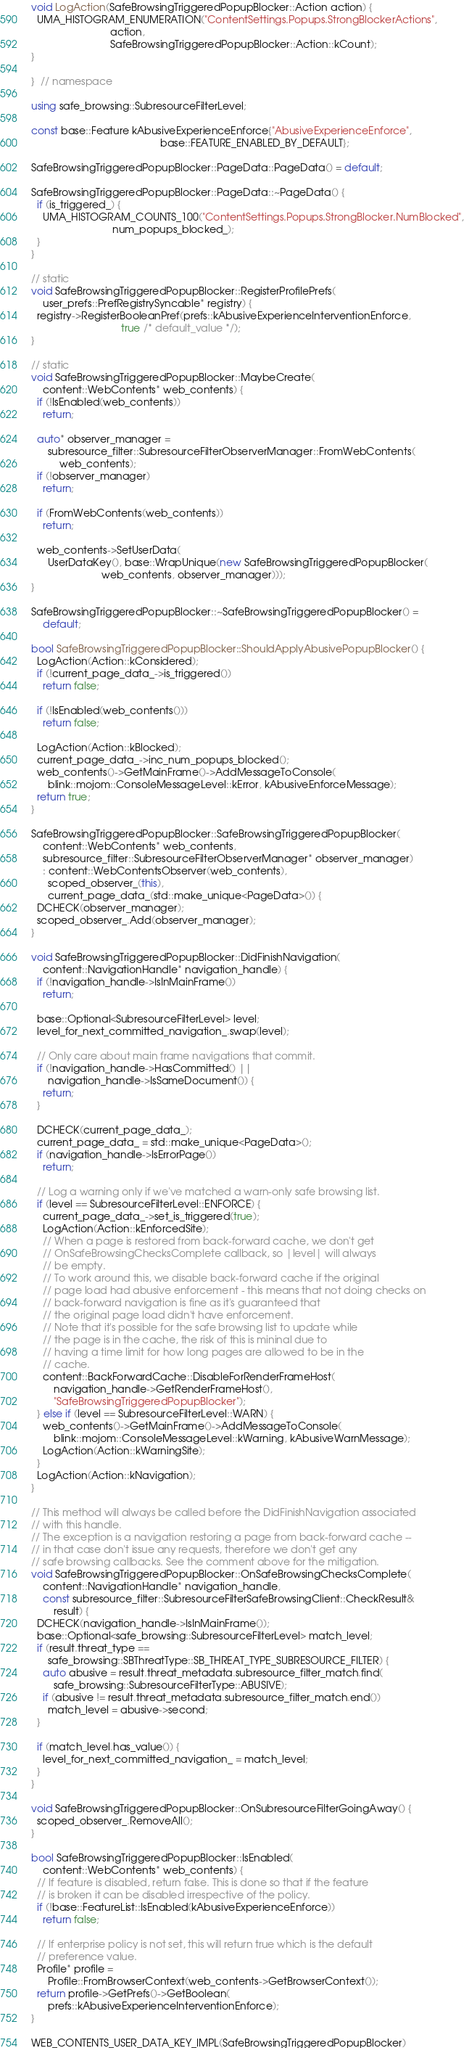Convert code to text. <code><loc_0><loc_0><loc_500><loc_500><_C++_>
void LogAction(SafeBrowsingTriggeredPopupBlocker::Action action) {
  UMA_HISTOGRAM_ENUMERATION("ContentSettings.Popups.StrongBlockerActions",
                            action,
                            SafeBrowsingTriggeredPopupBlocker::Action::kCount);
}

}  // namespace

using safe_browsing::SubresourceFilterLevel;

const base::Feature kAbusiveExperienceEnforce{"AbusiveExperienceEnforce",
                                              base::FEATURE_ENABLED_BY_DEFAULT};

SafeBrowsingTriggeredPopupBlocker::PageData::PageData() = default;

SafeBrowsingTriggeredPopupBlocker::PageData::~PageData() {
  if (is_triggered_) {
    UMA_HISTOGRAM_COUNTS_100("ContentSettings.Popups.StrongBlocker.NumBlocked",
                             num_popups_blocked_);
  }
}

// static
void SafeBrowsingTriggeredPopupBlocker::RegisterProfilePrefs(
    user_prefs::PrefRegistrySyncable* registry) {
  registry->RegisterBooleanPref(prefs::kAbusiveExperienceInterventionEnforce,
                                true /* default_value */);
}

// static
void SafeBrowsingTriggeredPopupBlocker::MaybeCreate(
    content::WebContents* web_contents) {
  if (!IsEnabled(web_contents))
    return;

  auto* observer_manager =
      subresource_filter::SubresourceFilterObserverManager::FromWebContents(
          web_contents);
  if (!observer_manager)
    return;

  if (FromWebContents(web_contents))
    return;

  web_contents->SetUserData(
      UserDataKey(), base::WrapUnique(new SafeBrowsingTriggeredPopupBlocker(
                         web_contents, observer_manager)));
}

SafeBrowsingTriggeredPopupBlocker::~SafeBrowsingTriggeredPopupBlocker() =
    default;

bool SafeBrowsingTriggeredPopupBlocker::ShouldApplyAbusivePopupBlocker() {
  LogAction(Action::kConsidered);
  if (!current_page_data_->is_triggered())
    return false;

  if (!IsEnabled(web_contents()))
    return false;

  LogAction(Action::kBlocked);
  current_page_data_->inc_num_popups_blocked();
  web_contents()->GetMainFrame()->AddMessageToConsole(
      blink::mojom::ConsoleMessageLevel::kError, kAbusiveEnforceMessage);
  return true;
}

SafeBrowsingTriggeredPopupBlocker::SafeBrowsingTriggeredPopupBlocker(
    content::WebContents* web_contents,
    subresource_filter::SubresourceFilterObserverManager* observer_manager)
    : content::WebContentsObserver(web_contents),
      scoped_observer_(this),
      current_page_data_(std::make_unique<PageData>()) {
  DCHECK(observer_manager);
  scoped_observer_.Add(observer_manager);
}

void SafeBrowsingTriggeredPopupBlocker::DidFinishNavigation(
    content::NavigationHandle* navigation_handle) {
  if (!navigation_handle->IsInMainFrame())
    return;

  base::Optional<SubresourceFilterLevel> level;
  level_for_next_committed_navigation_.swap(level);

  // Only care about main frame navigations that commit.
  if (!navigation_handle->HasCommitted() ||
      navigation_handle->IsSameDocument()) {
    return;
  }

  DCHECK(current_page_data_);
  current_page_data_ = std::make_unique<PageData>();
  if (navigation_handle->IsErrorPage())
    return;

  // Log a warning only if we've matched a warn-only safe browsing list.
  if (level == SubresourceFilterLevel::ENFORCE) {
    current_page_data_->set_is_triggered(true);
    LogAction(Action::kEnforcedSite);
    // When a page is restored from back-forward cache, we don't get
    // OnSafeBrowsingChecksComplete callback, so |level| will always
    // be empty.
    // To work around this, we disable back-forward cache if the original
    // page load had abusive enforcement - this means that not doing checks on
    // back-forward navigation is fine as it's guaranteed that
    // the original page load didn't have enforcement.
    // Note that it's possible for the safe browsing list to update while
    // the page is in the cache, the risk of this is mininal due to
    // having a time limit for how long pages are allowed to be in the
    // cache.
    content::BackForwardCache::DisableForRenderFrameHost(
        navigation_handle->GetRenderFrameHost(),
        "SafeBrowsingTriggeredPopupBlocker");
  } else if (level == SubresourceFilterLevel::WARN) {
    web_contents()->GetMainFrame()->AddMessageToConsole(
        blink::mojom::ConsoleMessageLevel::kWarning, kAbusiveWarnMessage);
    LogAction(Action::kWarningSite);
  }
  LogAction(Action::kNavigation);
}

// This method will always be called before the DidFinishNavigation associated
// with this handle.
// The exception is a navigation restoring a page from back-forward cache --
// in that case don't issue any requests, therefore we don't get any
// safe browsing callbacks. See the comment above for the mitigation.
void SafeBrowsingTriggeredPopupBlocker::OnSafeBrowsingChecksComplete(
    content::NavigationHandle* navigation_handle,
    const subresource_filter::SubresourceFilterSafeBrowsingClient::CheckResult&
        result) {
  DCHECK(navigation_handle->IsInMainFrame());
  base::Optional<safe_browsing::SubresourceFilterLevel> match_level;
  if (result.threat_type ==
      safe_browsing::SBThreatType::SB_THREAT_TYPE_SUBRESOURCE_FILTER) {
    auto abusive = result.threat_metadata.subresource_filter_match.find(
        safe_browsing::SubresourceFilterType::ABUSIVE);
    if (abusive != result.threat_metadata.subresource_filter_match.end())
      match_level = abusive->second;
  }

  if (match_level.has_value()) {
    level_for_next_committed_navigation_ = match_level;
  }
}

void SafeBrowsingTriggeredPopupBlocker::OnSubresourceFilterGoingAway() {
  scoped_observer_.RemoveAll();
}

bool SafeBrowsingTriggeredPopupBlocker::IsEnabled(
    content::WebContents* web_contents) {
  // If feature is disabled, return false. This is done so that if the feature
  // is broken it can be disabled irrespective of the policy.
  if (!base::FeatureList::IsEnabled(kAbusiveExperienceEnforce))
    return false;

  // If enterprise policy is not set, this will return true which is the default
  // preference value.
  Profile* profile =
      Profile::FromBrowserContext(web_contents->GetBrowserContext());
  return profile->GetPrefs()->GetBoolean(
      prefs::kAbusiveExperienceInterventionEnforce);
}

WEB_CONTENTS_USER_DATA_KEY_IMPL(SafeBrowsingTriggeredPopupBlocker)
</code> 